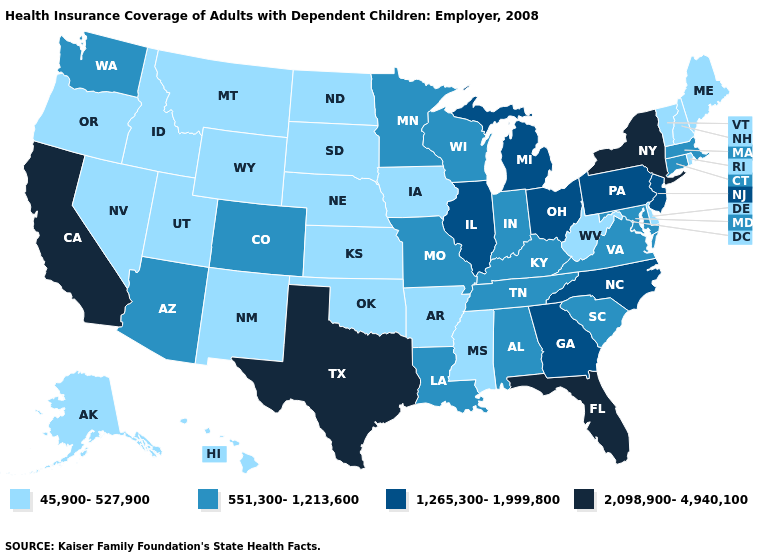Among the states that border Kansas , does Oklahoma have the highest value?
Write a very short answer. No. What is the lowest value in the USA?
Quick response, please. 45,900-527,900. How many symbols are there in the legend?
Quick response, please. 4. What is the lowest value in states that border Arizona?
Concise answer only. 45,900-527,900. Name the states that have a value in the range 1,265,300-1,999,800?
Concise answer only. Georgia, Illinois, Michigan, New Jersey, North Carolina, Ohio, Pennsylvania. Name the states that have a value in the range 45,900-527,900?
Short answer required. Alaska, Arkansas, Delaware, Hawaii, Idaho, Iowa, Kansas, Maine, Mississippi, Montana, Nebraska, Nevada, New Hampshire, New Mexico, North Dakota, Oklahoma, Oregon, Rhode Island, South Dakota, Utah, Vermont, West Virginia, Wyoming. Name the states that have a value in the range 551,300-1,213,600?
Short answer required. Alabama, Arizona, Colorado, Connecticut, Indiana, Kentucky, Louisiana, Maryland, Massachusetts, Minnesota, Missouri, South Carolina, Tennessee, Virginia, Washington, Wisconsin. What is the highest value in states that border Vermont?
Short answer required. 2,098,900-4,940,100. Does the map have missing data?
Write a very short answer. No. Is the legend a continuous bar?
Concise answer only. No. Which states have the highest value in the USA?
Answer briefly. California, Florida, New York, Texas. Name the states that have a value in the range 1,265,300-1,999,800?
Concise answer only. Georgia, Illinois, Michigan, New Jersey, North Carolina, Ohio, Pennsylvania. What is the value of Hawaii?
Be succinct. 45,900-527,900. What is the value of South Carolina?
Quick response, please. 551,300-1,213,600. What is the highest value in the South ?
Quick response, please. 2,098,900-4,940,100. 